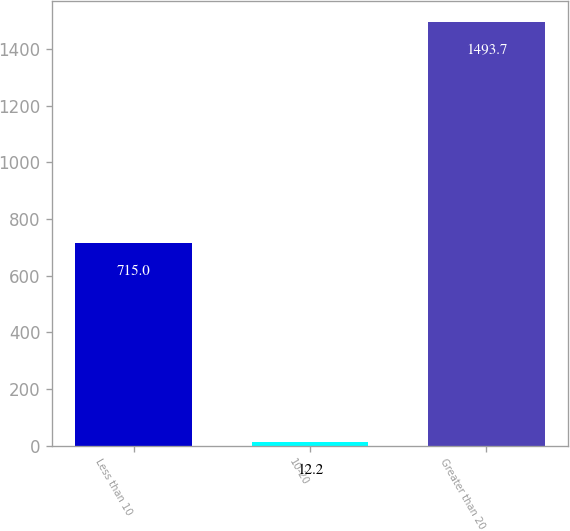<chart> <loc_0><loc_0><loc_500><loc_500><bar_chart><fcel>Less than 10<fcel>10-20<fcel>Greater than 20<nl><fcel>715<fcel>12.2<fcel>1493.7<nl></chart> 